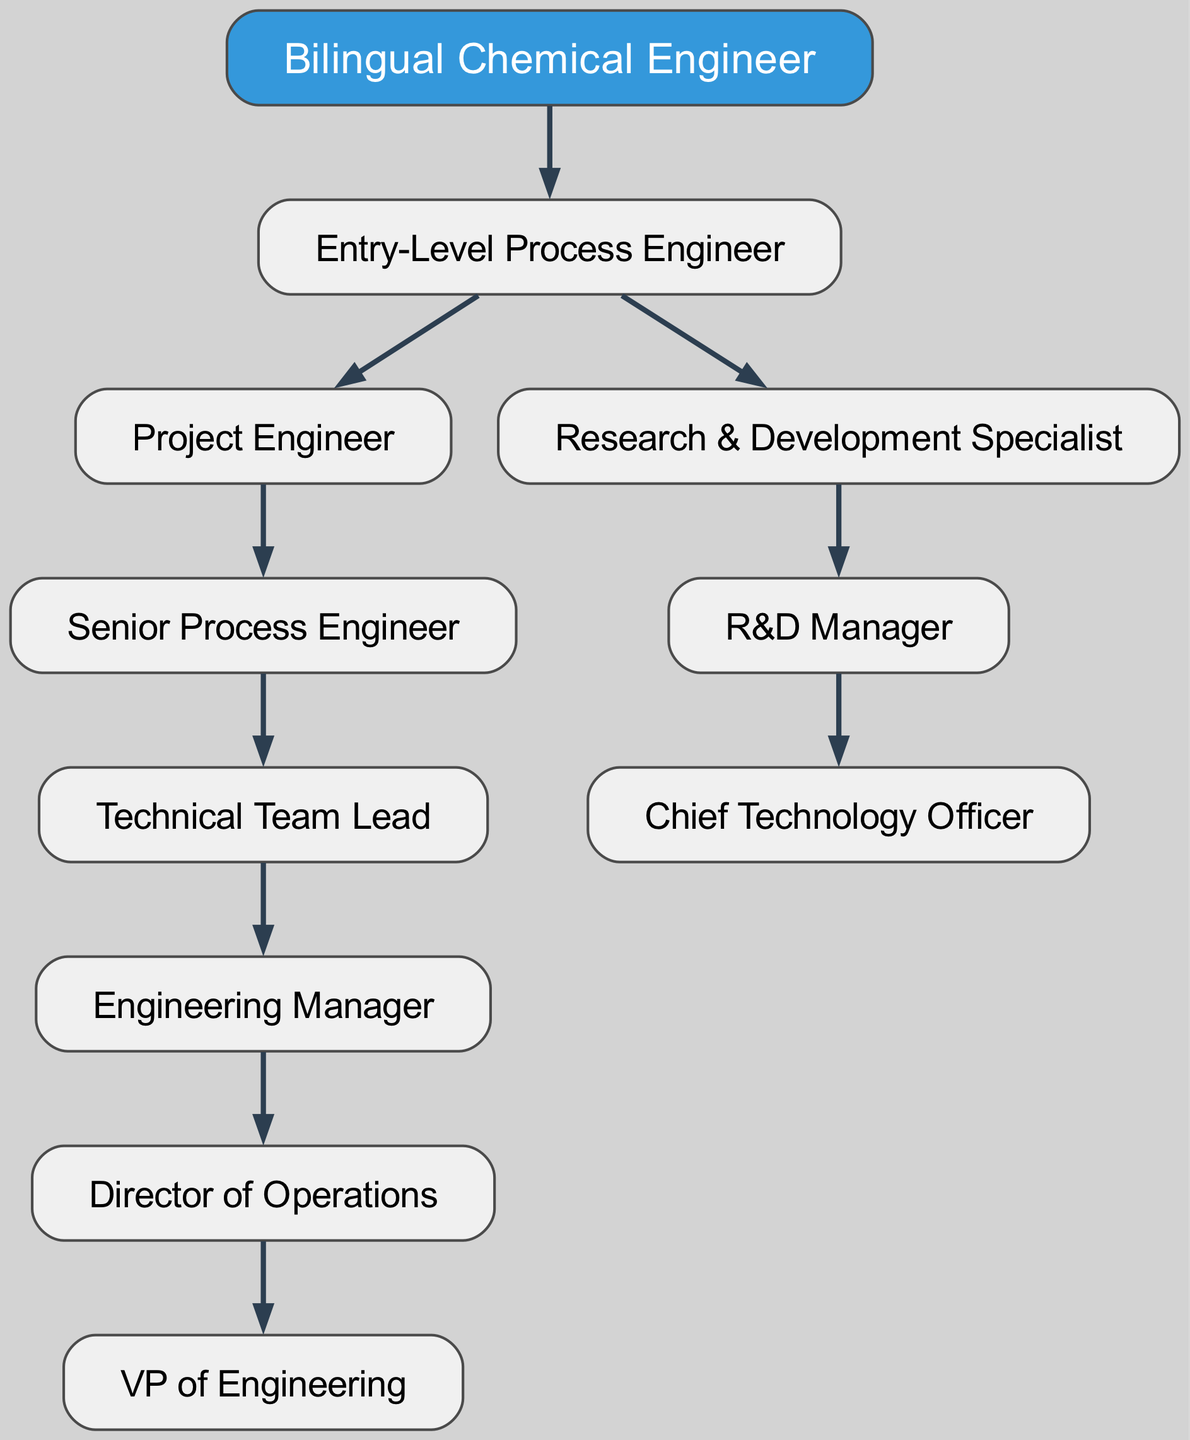What is the root node of the diagram? The root node is labeled "Bilingual Chemical Engineer." This is confirmed by the provided data structure where the "root" key directly points to this value.
Answer: Bilingual Chemical Engineer How many main pathways are there under the entry-level position? There are two main pathways under the "Entry-Level Process Engineer," which are "Project Engineer" and "Research & Development Specialist." This can be identified by counting the children of the first child node.
Answer: Two What is the position directly above the "Senior Process Engineer"? The position directly above "Senior Process Engineer" is "Project Engineer." This can be found by following the hierarchy, where "Project Engineer" is the parent node of "Senior Process Engineer."
Answer: Project Engineer What is the highest position in the career progression? The highest position in the career progression is "VP of Engineering." This is stated as the final node in the hierarchy under "Director of Operations."
Answer: VP of Engineering Which role comes immediately after "R&D Manager"? The role that comes immediately after "R&D Manager" is "Chief Technology Officer." This is identified by checking the children of "R&D Manager."
Answer: Chief Technology Officer Which position does not have any child nodes? The position "VP of Engineering" does not have any child nodes, making it a terminal node in the hierarchy. This can be ascertained by observing that it has no further descendants listed.
Answer: VP of Engineering What is the relationship between "Technical Team Lead" and "Engineering Manager"? "Technical Team Lead" is a direct predecessor of "Engineering Manager," indicating that it is one level lower in the hierarchy. This can be validated by following the structure from "Technical Team Lead" to "Engineering Manager."
Answer: Predecessor How many total positions are listed in the diagram? The total number of positions listed, including all nodes, can be counted manually or methodically based on the tree structure. In this case, there are eight distinct positions when all nodes are added together.
Answer: Eight Which two positions eventually lead to the role of "Chief Technology Officer"? The two positions that eventually lead to "Chief Technology Officer" are "Research & Development Specialist" and "R&D Manager." This can be deduced by tracing the hierarchy. "R&D Manager" has no other outputs, hence creating a path to "Chief Technology Officer."
Answer: Research & Development Specialist, R&D Manager 